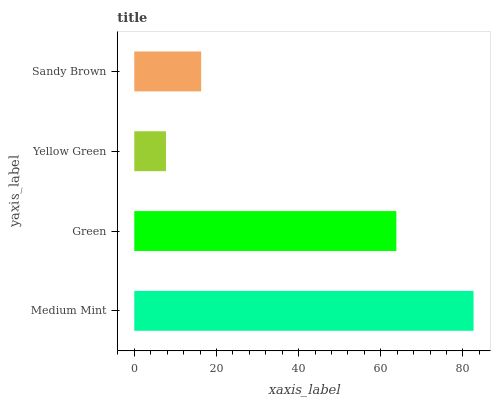Is Yellow Green the minimum?
Answer yes or no. Yes. Is Medium Mint the maximum?
Answer yes or no. Yes. Is Green the minimum?
Answer yes or no. No. Is Green the maximum?
Answer yes or no. No. Is Medium Mint greater than Green?
Answer yes or no. Yes. Is Green less than Medium Mint?
Answer yes or no. Yes. Is Green greater than Medium Mint?
Answer yes or no. No. Is Medium Mint less than Green?
Answer yes or no. No. Is Green the high median?
Answer yes or no. Yes. Is Sandy Brown the low median?
Answer yes or no. Yes. Is Yellow Green the high median?
Answer yes or no. No. Is Medium Mint the low median?
Answer yes or no. No. 